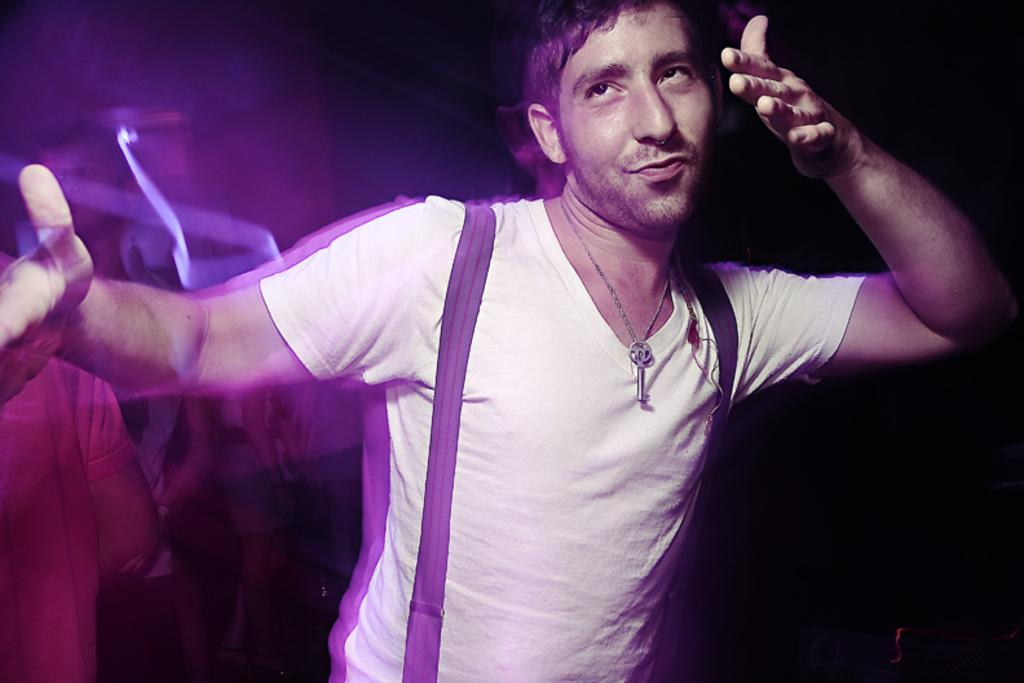What is the main subject of the image? There is a person in the image. What is the person wearing? The person is wearing a white T-shirt. What is the person doing in the image? The person is dancing. Are there any other people visible in the image? Yes, there are other persons in the left corner of the image. What type of cushion is being used by the person to play an instrument during the protest in the image? There is no cushion, instrument, or protest present in the image. The person is simply dancing while wearing a white T-shirt. 